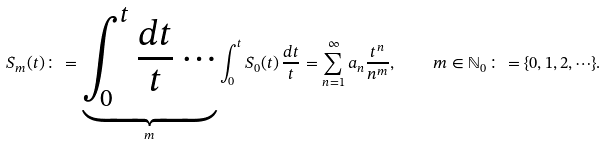<formula> <loc_0><loc_0><loc_500><loc_500>S _ { m } ( t ) \colon = \underbrace { \int ^ { t } _ { 0 } \frac { d t } { t } \cdots } _ { m } \int ^ { t } _ { 0 } S _ { 0 } ( t ) \, \frac { d t } { t } = \sum ^ { \infty } _ { n = 1 } a _ { n } \frac { t ^ { n } } { n ^ { m } } , \quad m \in \mathbb { N } _ { 0 } \colon = \{ 0 , 1 , 2 , \cdots \} .</formula> 